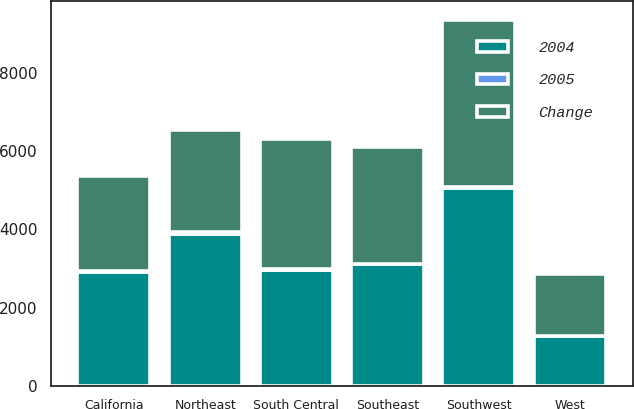Convert chart. <chart><loc_0><loc_0><loc_500><loc_500><stacked_bar_chart><ecel><fcel>Northeast<fcel>Southeast<fcel>South Central<fcel>Southwest<fcel>California<fcel>West<nl><fcel>2004<fcel>3894<fcel>3119<fcel>2975<fcel>5068<fcel>2922<fcel>1266<nl><fcel>Change<fcel>2608<fcel>2980<fcel>3321<fcel>4279<fcel>2422<fcel>1574<nl><fcel>2005<fcel>49<fcel>5<fcel>10<fcel>18<fcel>21<fcel>20<nl></chart> 